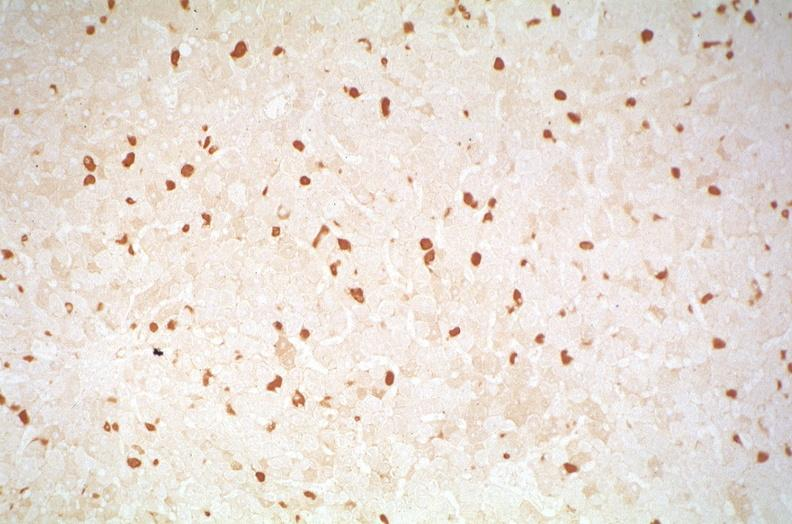does this image show hepatitis b virus, hepatocellular carcinoma?
Answer the question using a single word or phrase. Yes 